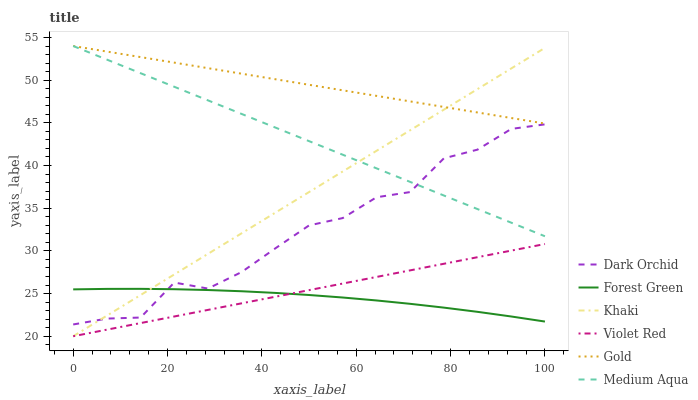Does Forest Green have the minimum area under the curve?
Answer yes or no. Yes. Does Gold have the maximum area under the curve?
Answer yes or no. Yes. Does Khaki have the minimum area under the curve?
Answer yes or no. No. Does Khaki have the maximum area under the curve?
Answer yes or no. No. Is Violet Red the smoothest?
Answer yes or no. Yes. Is Dark Orchid the roughest?
Answer yes or no. Yes. Is Khaki the smoothest?
Answer yes or no. No. Is Khaki the roughest?
Answer yes or no. No. Does Violet Red have the lowest value?
Answer yes or no. Yes. Does Gold have the lowest value?
Answer yes or no. No. Does Medium Aqua have the highest value?
Answer yes or no. Yes. Does Khaki have the highest value?
Answer yes or no. No. Is Forest Green less than Gold?
Answer yes or no. Yes. Is Medium Aqua greater than Violet Red?
Answer yes or no. Yes. Does Dark Orchid intersect Forest Green?
Answer yes or no. Yes. Is Dark Orchid less than Forest Green?
Answer yes or no. No. Is Dark Orchid greater than Forest Green?
Answer yes or no. No. Does Forest Green intersect Gold?
Answer yes or no. No. 